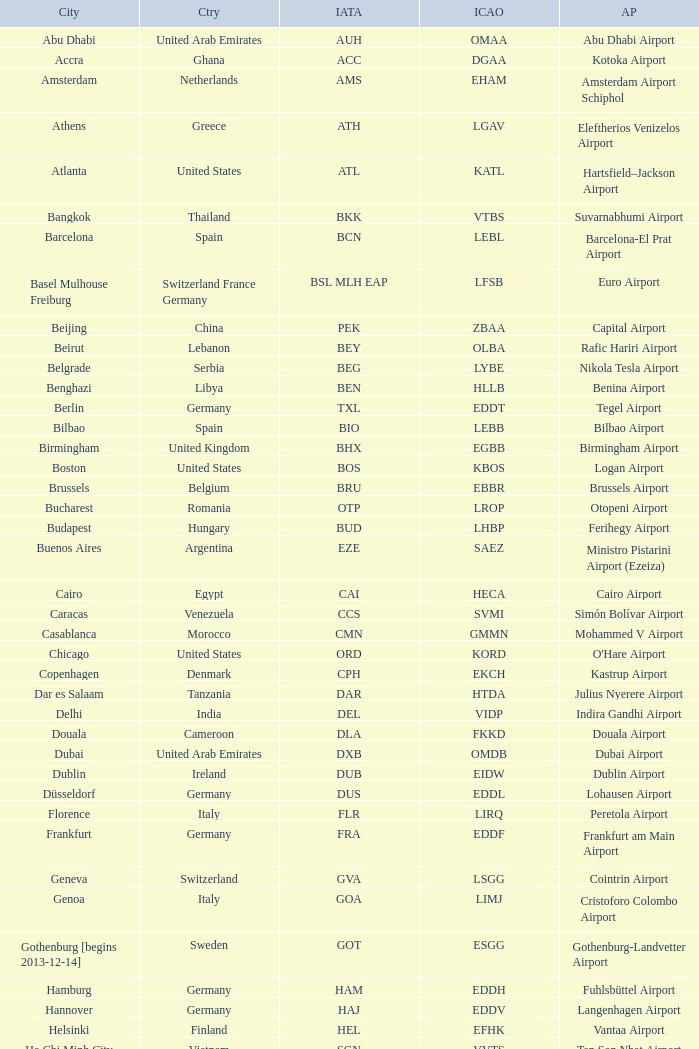Could you parse the entire table? {'header': ['City', 'Ctry', 'IATA', 'ICAO', 'AP'], 'rows': [['Abu Dhabi', 'United Arab Emirates', 'AUH', 'OMAA', 'Abu Dhabi Airport'], ['Accra', 'Ghana', 'ACC', 'DGAA', 'Kotoka Airport'], ['Amsterdam', 'Netherlands', 'AMS', 'EHAM', 'Amsterdam Airport Schiphol'], ['Athens', 'Greece', 'ATH', 'LGAV', 'Eleftherios Venizelos Airport'], ['Atlanta', 'United States', 'ATL', 'KATL', 'Hartsfield–Jackson Airport'], ['Bangkok', 'Thailand', 'BKK', 'VTBS', 'Suvarnabhumi Airport'], ['Barcelona', 'Spain', 'BCN', 'LEBL', 'Barcelona-El Prat Airport'], ['Basel Mulhouse Freiburg', 'Switzerland France Germany', 'BSL MLH EAP', 'LFSB', 'Euro Airport'], ['Beijing', 'China', 'PEK', 'ZBAA', 'Capital Airport'], ['Beirut', 'Lebanon', 'BEY', 'OLBA', 'Rafic Hariri Airport'], ['Belgrade', 'Serbia', 'BEG', 'LYBE', 'Nikola Tesla Airport'], ['Benghazi', 'Libya', 'BEN', 'HLLB', 'Benina Airport'], ['Berlin', 'Germany', 'TXL', 'EDDT', 'Tegel Airport'], ['Bilbao', 'Spain', 'BIO', 'LEBB', 'Bilbao Airport'], ['Birmingham', 'United Kingdom', 'BHX', 'EGBB', 'Birmingham Airport'], ['Boston', 'United States', 'BOS', 'KBOS', 'Logan Airport'], ['Brussels', 'Belgium', 'BRU', 'EBBR', 'Brussels Airport'], ['Bucharest', 'Romania', 'OTP', 'LROP', 'Otopeni Airport'], ['Budapest', 'Hungary', 'BUD', 'LHBP', 'Ferihegy Airport'], ['Buenos Aires', 'Argentina', 'EZE', 'SAEZ', 'Ministro Pistarini Airport (Ezeiza)'], ['Cairo', 'Egypt', 'CAI', 'HECA', 'Cairo Airport'], ['Caracas', 'Venezuela', 'CCS', 'SVMI', 'Simón Bolívar Airport'], ['Casablanca', 'Morocco', 'CMN', 'GMMN', 'Mohammed V Airport'], ['Chicago', 'United States', 'ORD', 'KORD', "O'Hare Airport"], ['Copenhagen', 'Denmark', 'CPH', 'EKCH', 'Kastrup Airport'], ['Dar es Salaam', 'Tanzania', 'DAR', 'HTDA', 'Julius Nyerere Airport'], ['Delhi', 'India', 'DEL', 'VIDP', 'Indira Gandhi Airport'], ['Douala', 'Cameroon', 'DLA', 'FKKD', 'Douala Airport'], ['Dubai', 'United Arab Emirates', 'DXB', 'OMDB', 'Dubai Airport'], ['Dublin', 'Ireland', 'DUB', 'EIDW', 'Dublin Airport'], ['Düsseldorf', 'Germany', 'DUS', 'EDDL', 'Lohausen Airport'], ['Florence', 'Italy', 'FLR', 'LIRQ', 'Peretola Airport'], ['Frankfurt', 'Germany', 'FRA', 'EDDF', 'Frankfurt am Main Airport'], ['Geneva', 'Switzerland', 'GVA', 'LSGG', 'Cointrin Airport'], ['Genoa', 'Italy', 'GOA', 'LIMJ', 'Cristoforo Colombo Airport'], ['Gothenburg [begins 2013-12-14]', 'Sweden', 'GOT', 'ESGG', 'Gothenburg-Landvetter Airport'], ['Hamburg', 'Germany', 'HAM', 'EDDH', 'Fuhlsbüttel Airport'], ['Hannover', 'Germany', 'HAJ', 'EDDV', 'Langenhagen Airport'], ['Helsinki', 'Finland', 'HEL', 'EFHK', 'Vantaa Airport'], ['Ho Chi Minh City', 'Vietnam', 'SGN', 'VVTS', 'Tan Son Nhat Airport'], ['Hong Kong', 'Hong Kong', 'HKG', 'VHHH', 'Chek Lap Kok Airport'], ['Istanbul', 'Turkey', 'IST', 'LTBA', 'Atatürk Airport'], ['Jakarta', 'Indonesia', 'CGK', 'WIII', 'Soekarno–Hatta Airport'], ['Jeddah', 'Saudi Arabia', 'JED', 'OEJN', 'King Abdulaziz Airport'], ['Johannesburg', 'South Africa', 'JNB', 'FAJS', 'OR Tambo Airport'], ['Karachi', 'Pakistan', 'KHI', 'OPKC', 'Jinnah Airport'], ['Kiev', 'Ukraine', 'KBP', 'UKBB', 'Boryspil International Airport'], ['Lagos', 'Nigeria', 'LOS', 'DNMM', 'Murtala Muhammed Airport'], ['Libreville', 'Gabon', 'LBV', 'FOOL', "Leon M'ba Airport"], ['Lisbon', 'Portugal', 'LIS', 'LPPT', 'Portela Airport'], ['London', 'United Kingdom', 'LCY', 'EGLC', 'City Airport'], ['London [begins 2013-12-14]', 'United Kingdom', 'LGW', 'EGKK', 'Gatwick Airport'], ['London', 'United Kingdom', 'LHR', 'EGLL', 'Heathrow Airport'], ['Los Angeles', 'United States', 'LAX', 'KLAX', 'Los Angeles International Airport'], ['Lugano', 'Switzerland', 'LUG', 'LSZA', 'Agno Airport'], ['Luxembourg City', 'Luxembourg', 'LUX', 'ELLX', 'Findel Airport'], ['Lyon', 'France', 'LYS', 'LFLL', 'Saint-Exupéry Airport'], ['Madrid', 'Spain', 'MAD', 'LEMD', 'Madrid-Barajas Airport'], ['Malabo', 'Equatorial Guinea', 'SSG', 'FGSL', 'Saint Isabel Airport'], ['Malaga', 'Spain', 'AGP', 'LEMG', 'Málaga-Costa del Sol Airport'], ['Manchester', 'United Kingdom', 'MAN', 'EGCC', 'Ringway Airport'], ['Manila', 'Philippines', 'MNL', 'RPLL', 'Ninoy Aquino Airport'], ['Marrakech [begins 2013-11-01]', 'Morocco', 'RAK', 'GMMX', 'Menara Airport'], ['Miami', 'United States', 'MIA', 'KMIA', 'Miami Airport'], ['Milan', 'Italy', 'MXP', 'LIMC', 'Malpensa Airport'], ['Minneapolis', 'United States', 'MSP', 'KMSP', 'Minneapolis Airport'], ['Montreal', 'Canada', 'YUL', 'CYUL', 'Pierre Elliott Trudeau Airport'], ['Moscow', 'Russia', 'DME', 'UUDD', 'Domodedovo Airport'], ['Mumbai', 'India', 'BOM', 'VABB', 'Chhatrapati Shivaji Airport'], ['Munich', 'Germany', 'MUC', 'EDDM', 'Franz Josef Strauss Airport'], ['Muscat', 'Oman', 'MCT', 'OOMS', 'Seeb Airport'], ['Nairobi', 'Kenya', 'NBO', 'HKJK', 'Jomo Kenyatta Airport'], ['Newark', 'United States', 'EWR', 'KEWR', 'Liberty Airport'], ['New York City', 'United States', 'JFK', 'KJFK', 'John F Kennedy Airport'], ['Nice', 'France', 'NCE', 'LFMN', "Côte d'Azur Airport"], ['Nuremberg', 'Germany', 'NUE', 'EDDN', 'Nuremberg Airport'], ['Oslo', 'Norway', 'OSL', 'ENGM', 'Gardermoen Airport'], ['Palma de Mallorca', 'Spain', 'PMI', 'LFPA', 'Palma de Mallorca Airport'], ['Paris', 'France', 'CDG', 'LFPG', 'Charles de Gaulle Airport'], ['Porto', 'Portugal', 'OPO', 'LPPR', 'Francisco de Sa Carneiro Airport'], ['Prague', 'Czech Republic', 'PRG', 'LKPR', 'Ruzyně Airport'], ['Riga', 'Latvia', 'RIX', 'EVRA', 'Riga Airport'], ['Rio de Janeiro [resumes 2014-7-14]', 'Brazil', 'GIG', 'SBGL', 'Galeão Airport'], ['Riyadh', 'Saudi Arabia', 'RUH', 'OERK', 'King Khalid Airport'], ['Rome', 'Italy', 'FCO', 'LIRF', 'Leonardo da Vinci Airport'], ['Saint Petersburg', 'Russia', 'LED', 'ULLI', 'Pulkovo Airport'], ['San Francisco', 'United States', 'SFO', 'KSFO', 'San Francisco Airport'], ['Santiago', 'Chile', 'SCL', 'SCEL', 'Comodoro Arturo Benitez Airport'], ['São Paulo', 'Brazil', 'GRU', 'SBGR', 'Guarulhos Airport'], ['Sarajevo', 'Bosnia and Herzegovina', 'SJJ', 'LQSA', 'Butmir Airport'], ['Seattle', 'United States', 'SEA', 'KSEA', 'Sea-Tac Airport'], ['Shanghai', 'China', 'PVG', 'ZSPD', 'Pudong Airport'], ['Singapore', 'Singapore', 'SIN', 'WSSS', 'Changi Airport'], ['Skopje', 'Republic of Macedonia', 'SKP', 'LWSK', 'Alexander the Great Airport'], ['Sofia', 'Bulgaria', 'SOF', 'LBSF', 'Vrazhdebna Airport'], ['Stockholm', 'Sweden', 'ARN', 'ESSA', 'Arlanda Airport'], ['Stuttgart', 'Germany', 'STR', 'EDDS', 'Echterdingen Airport'], ['Taipei', 'Taiwan', 'TPE', 'RCTP', 'Taoyuan Airport'], ['Tehran', 'Iran', 'IKA', 'OIIE', 'Imam Khomeini Airport'], ['Tel Aviv', 'Israel', 'TLV', 'LLBG', 'Ben Gurion Airport'], ['Thessaloniki', 'Greece', 'SKG', 'LGTS', 'Macedonia Airport'], ['Tirana', 'Albania', 'TIA', 'LATI', 'Nënë Tereza Airport'], ['Tokyo', 'Japan', 'NRT', 'RJAA', 'Narita Airport'], ['Toronto', 'Canada', 'YYZ', 'CYYZ', 'Pearson Airport'], ['Tripoli', 'Libya', 'TIP', 'HLLT', 'Tripoli Airport'], ['Tunis', 'Tunisia', 'TUN', 'DTTA', 'Carthage Airport'], ['Turin', 'Italy', 'TRN', 'LIMF', 'Sandro Pertini Airport'], ['Valencia', 'Spain', 'VLC', 'LEVC', 'Valencia Airport'], ['Venice', 'Italy', 'VCE', 'LIPZ', 'Marco Polo Airport'], ['Vienna', 'Austria', 'VIE', 'LOWW', 'Schwechat Airport'], ['Warsaw', 'Poland', 'WAW', 'EPWA', 'Frederic Chopin Airport'], ['Washington DC', 'United States', 'IAD', 'KIAD', 'Dulles Airport'], ['Yaounde', 'Cameroon', 'NSI', 'FKYS', 'Yaounde Nsimalen Airport'], ['Yerevan', 'Armenia', 'EVN', 'UDYZ', 'Zvartnots Airport'], ['Zurich', 'Switzerland', 'ZRH', 'LSZH', 'Zurich Airport']]} What is the ICAO of Lohausen airport? EDDL. 